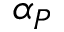<formula> <loc_0><loc_0><loc_500><loc_500>\alpha _ { P }</formula> 